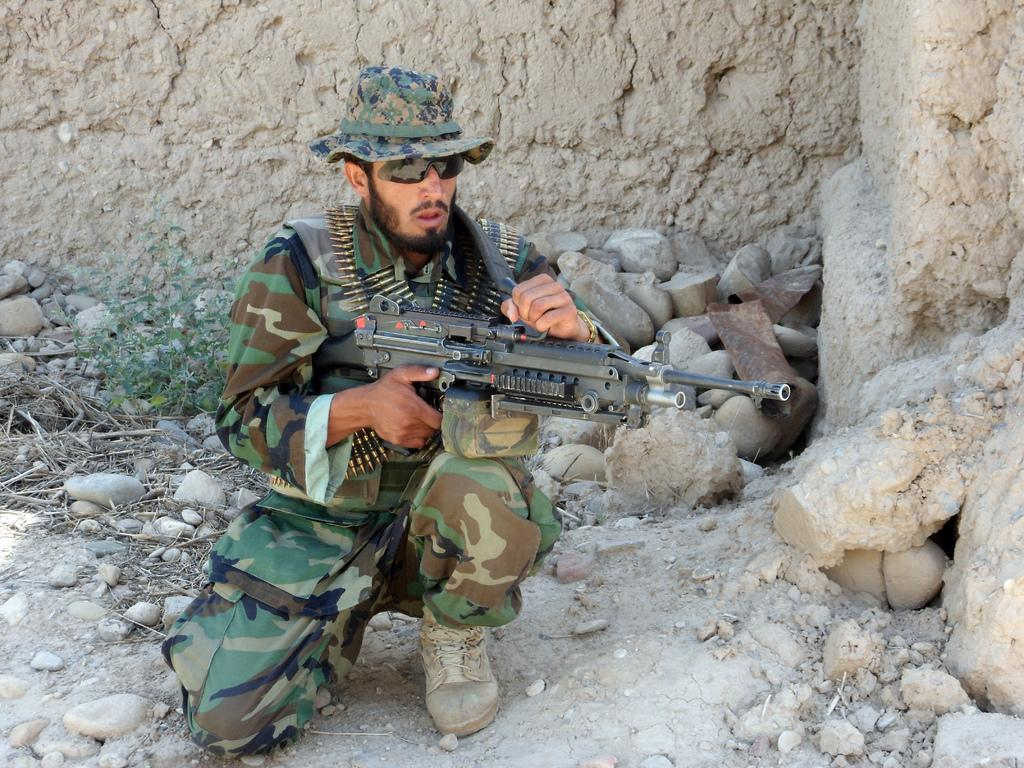What is the person in the image holding? The person in the image is holding a gun. What type of natural elements can be seen in the image? There are stones and a plant visible in the image. What material is present in the image besides the stones and plant? There is wood in the image. What can be seen in the background of the image? There is a wall in the background of the image. Can you tell me where the wren is located in the image? There is no wren present in the image. What type of office furniture can be seen in the image? There is no office furniture present in the image. 